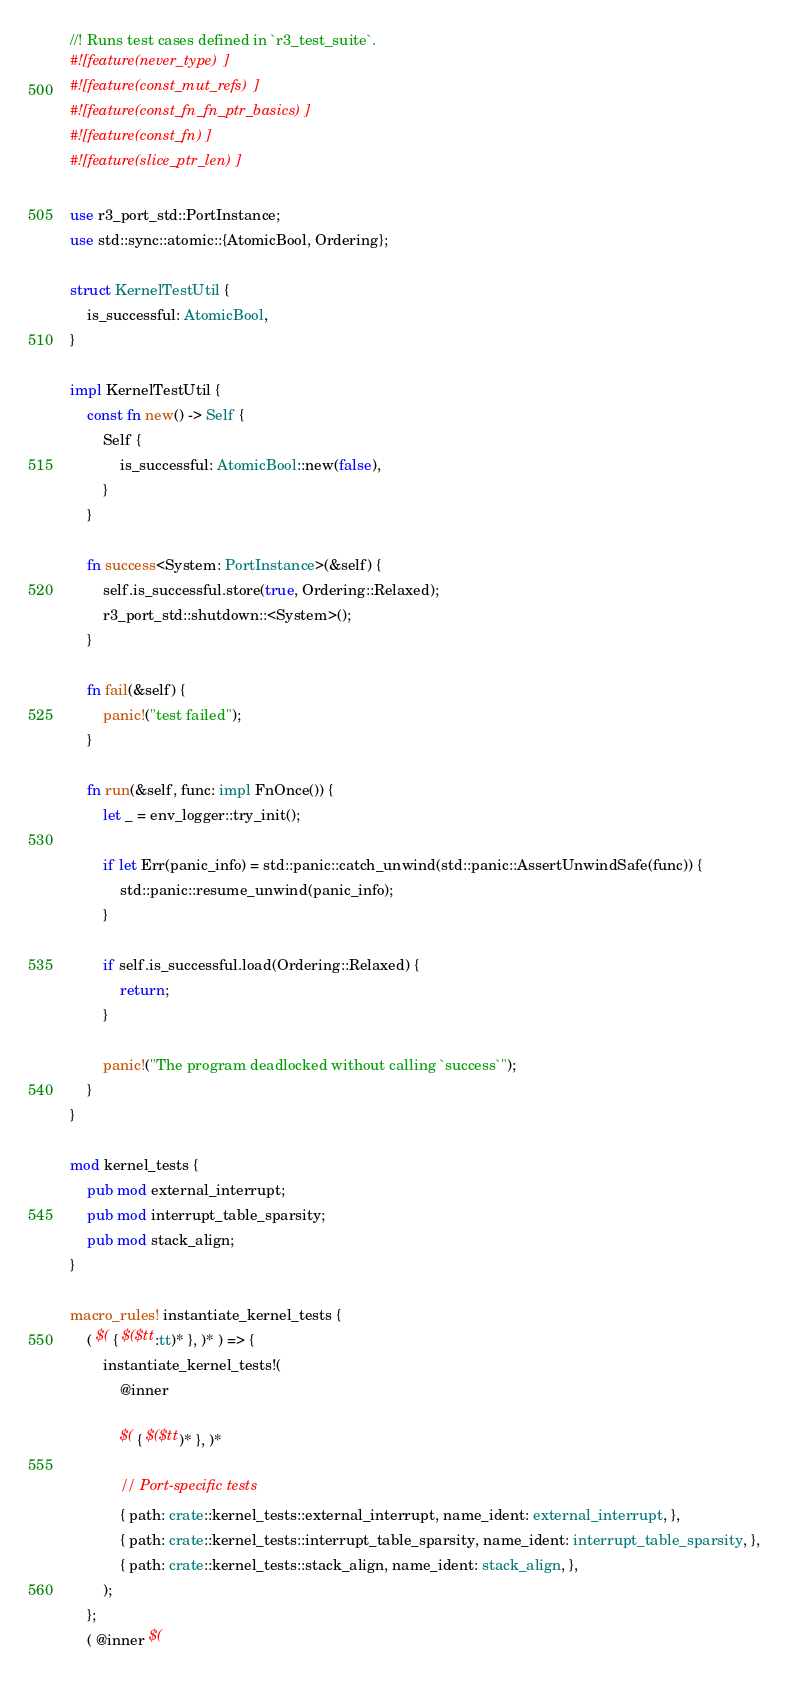Convert code to text. <code><loc_0><loc_0><loc_500><loc_500><_Rust_>//! Runs test cases defined in `r3_test_suite`.
#![feature(never_type)]
#![feature(const_mut_refs)]
#![feature(const_fn_fn_ptr_basics)]
#![feature(const_fn)]
#![feature(slice_ptr_len)]

use r3_port_std::PortInstance;
use std::sync::atomic::{AtomicBool, Ordering};

struct KernelTestUtil {
    is_successful: AtomicBool,
}

impl KernelTestUtil {
    const fn new() -> Self {
        Self {
            is_successful: AtomicBool::new(false),
        }
    }

    fn success<System: PortInstance>(&self) {
        self.is_successful.store(true, Ordering::Relaxed);
        r3_port_std::shutdown::<System>();
    }

    fn fail(&self) {
        panic!("test failed");
    }

    fn run(&self, func: impl FnOnce()) {
        let _ = env_logger::try_init();

        if let Err(panic_info) = std::panic::catch_unwind(std::panic::AssertUnwindSafe(func)) {
            std::panic::resume_unwind(panic_info);
        }

        if self.is_successful.load(Ordering::Relaxed) {
            return;
        }

        panic!("The program deadlocked without calling `success`");
    }
}

mod kernel_tests {
    pub mod external_interrupt;
    pub mod interrupt_table_sparsity;
    pub mod stack_align;
}

macro_rules! instantiate_kernel_tests {
    ( $( { $($tt:tt)* }, )* ) => {
        instantiate_kernel_tests!(
            @inner

            $( { $($tt)* }, )*

            // Port-specific tests
            { path: crate::kernel_tests::external_interrupt, name_ident: external_interrupt, },
            { path: crate::kernel_tests::interrupt_table_sparsity, name_ident: interrupt_table_sparsity, },
            { path: crate::kernel_tests::stack_align, name_ident: stack_align, },
        );
    };
    ( @inner $(</code> 